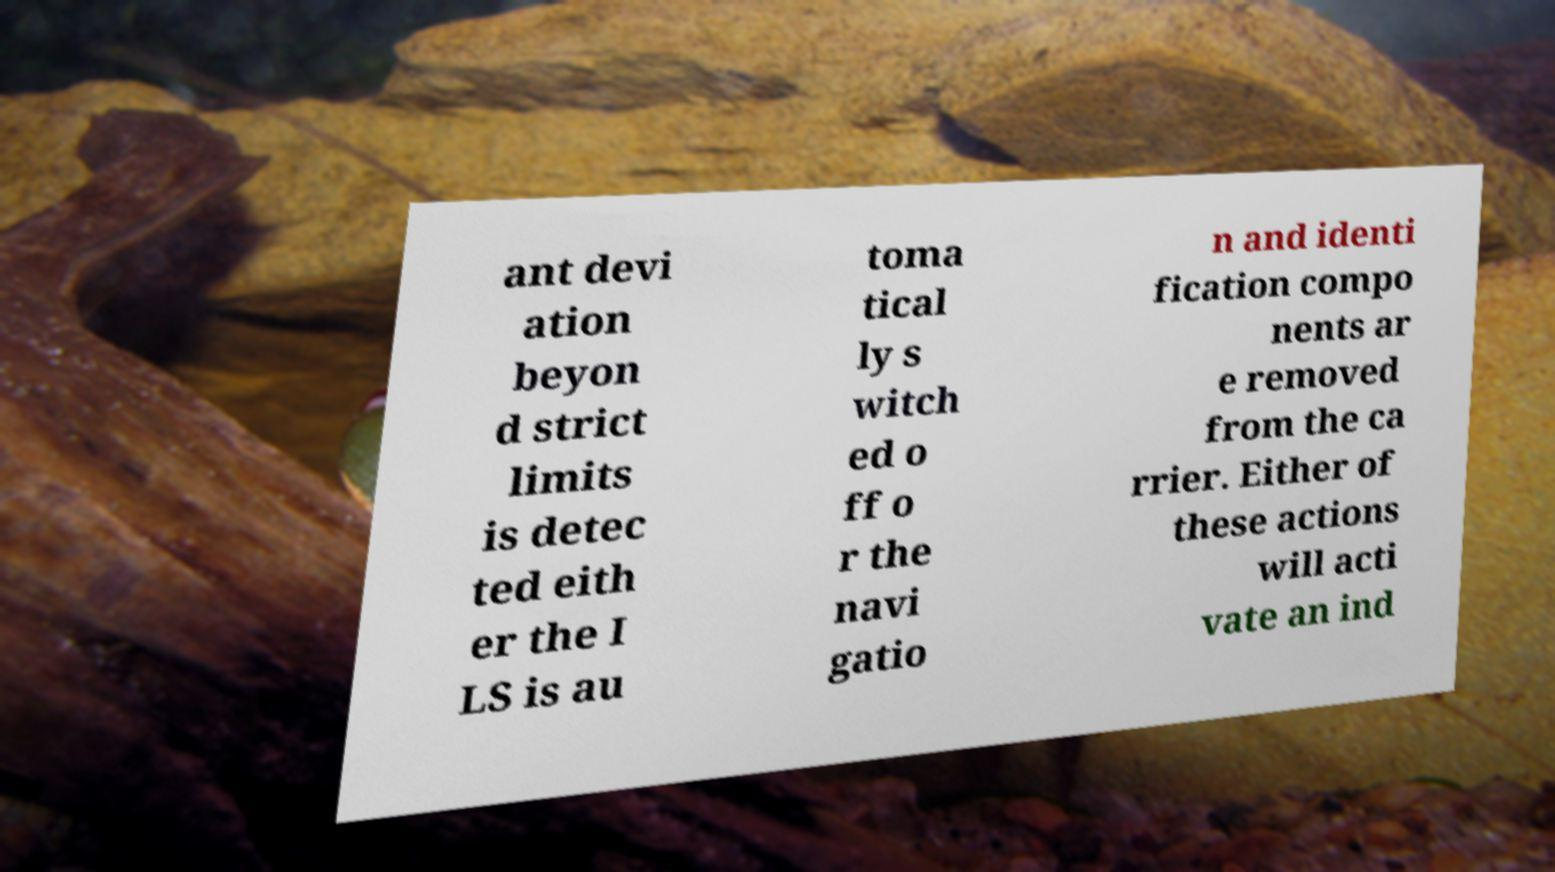Could you extract and type out the text from this image? ant devi ation beyon d strict limits is detec ted eith er the I LS is au toma tical ly s witch ed o ff o r the navi gatio n and identi fication compo nents ar e removed from the ca rrier. Either of these actions will acti vate an ind 